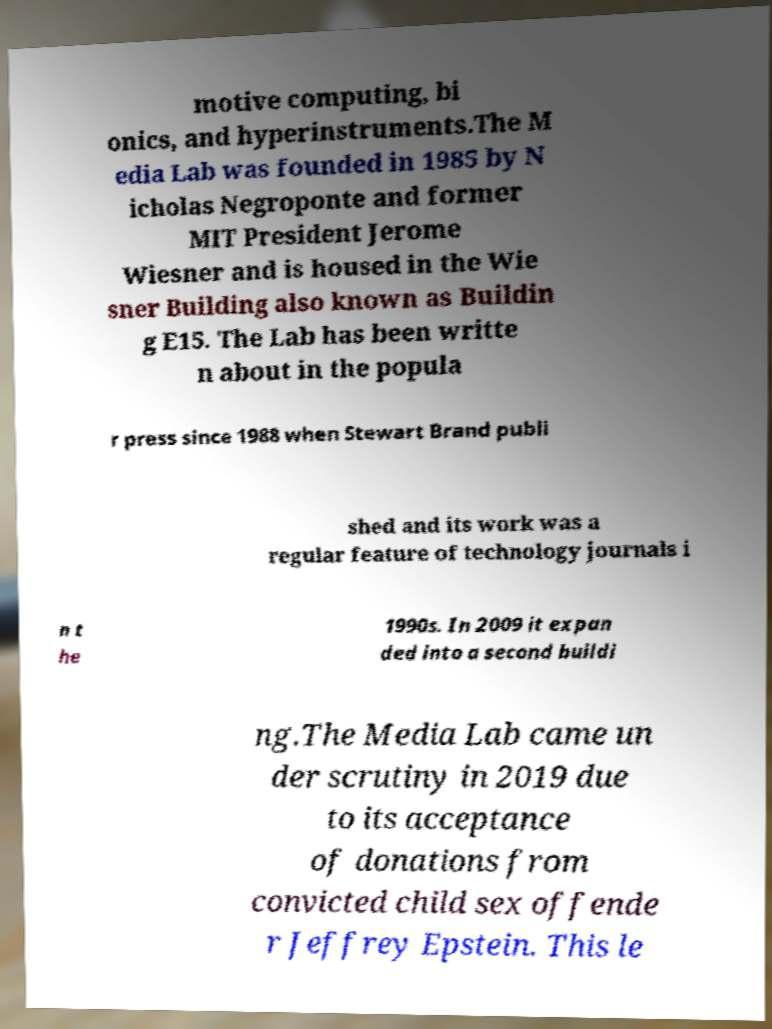Please identify and transcribe the text found in this image. motive computing, bi onics, and hyperinstruments.The M edia Lab was founded in 1985 by N icholas Negroponte and former MIT President Jerome Wiesner and is housed in the Wie sner Building also known as Buildin g E15. The Lab has been writte n about in the popula r press since 1988 when Stewart Brand publi shed and its work was a regular feature of technology journals i n t he 1990s. In 2009 it expan ded into a second buildi ng.The Media Lab came un der scrutiny in 2019 due to its acceptance of donations from convicted child sex offende r Jeffrey Epstein. This le 